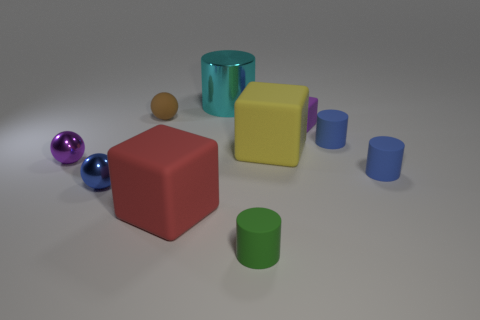Subtract all green blocks. Subtract all red balls. How many blocks are left? 3 Subtract all cylinders. How many objects are left? 6 Subtract 1 brown spheres. How many objects are left? 9 Subtract all blue metallic things. Subtract all big green metal blocks. How many objects are left? 9 Add 6 yellow rubber things. How many yellow rubber things are left? 7 Add 9 gray rubber cylinders. How many gray rubber cylinders exist? 9 